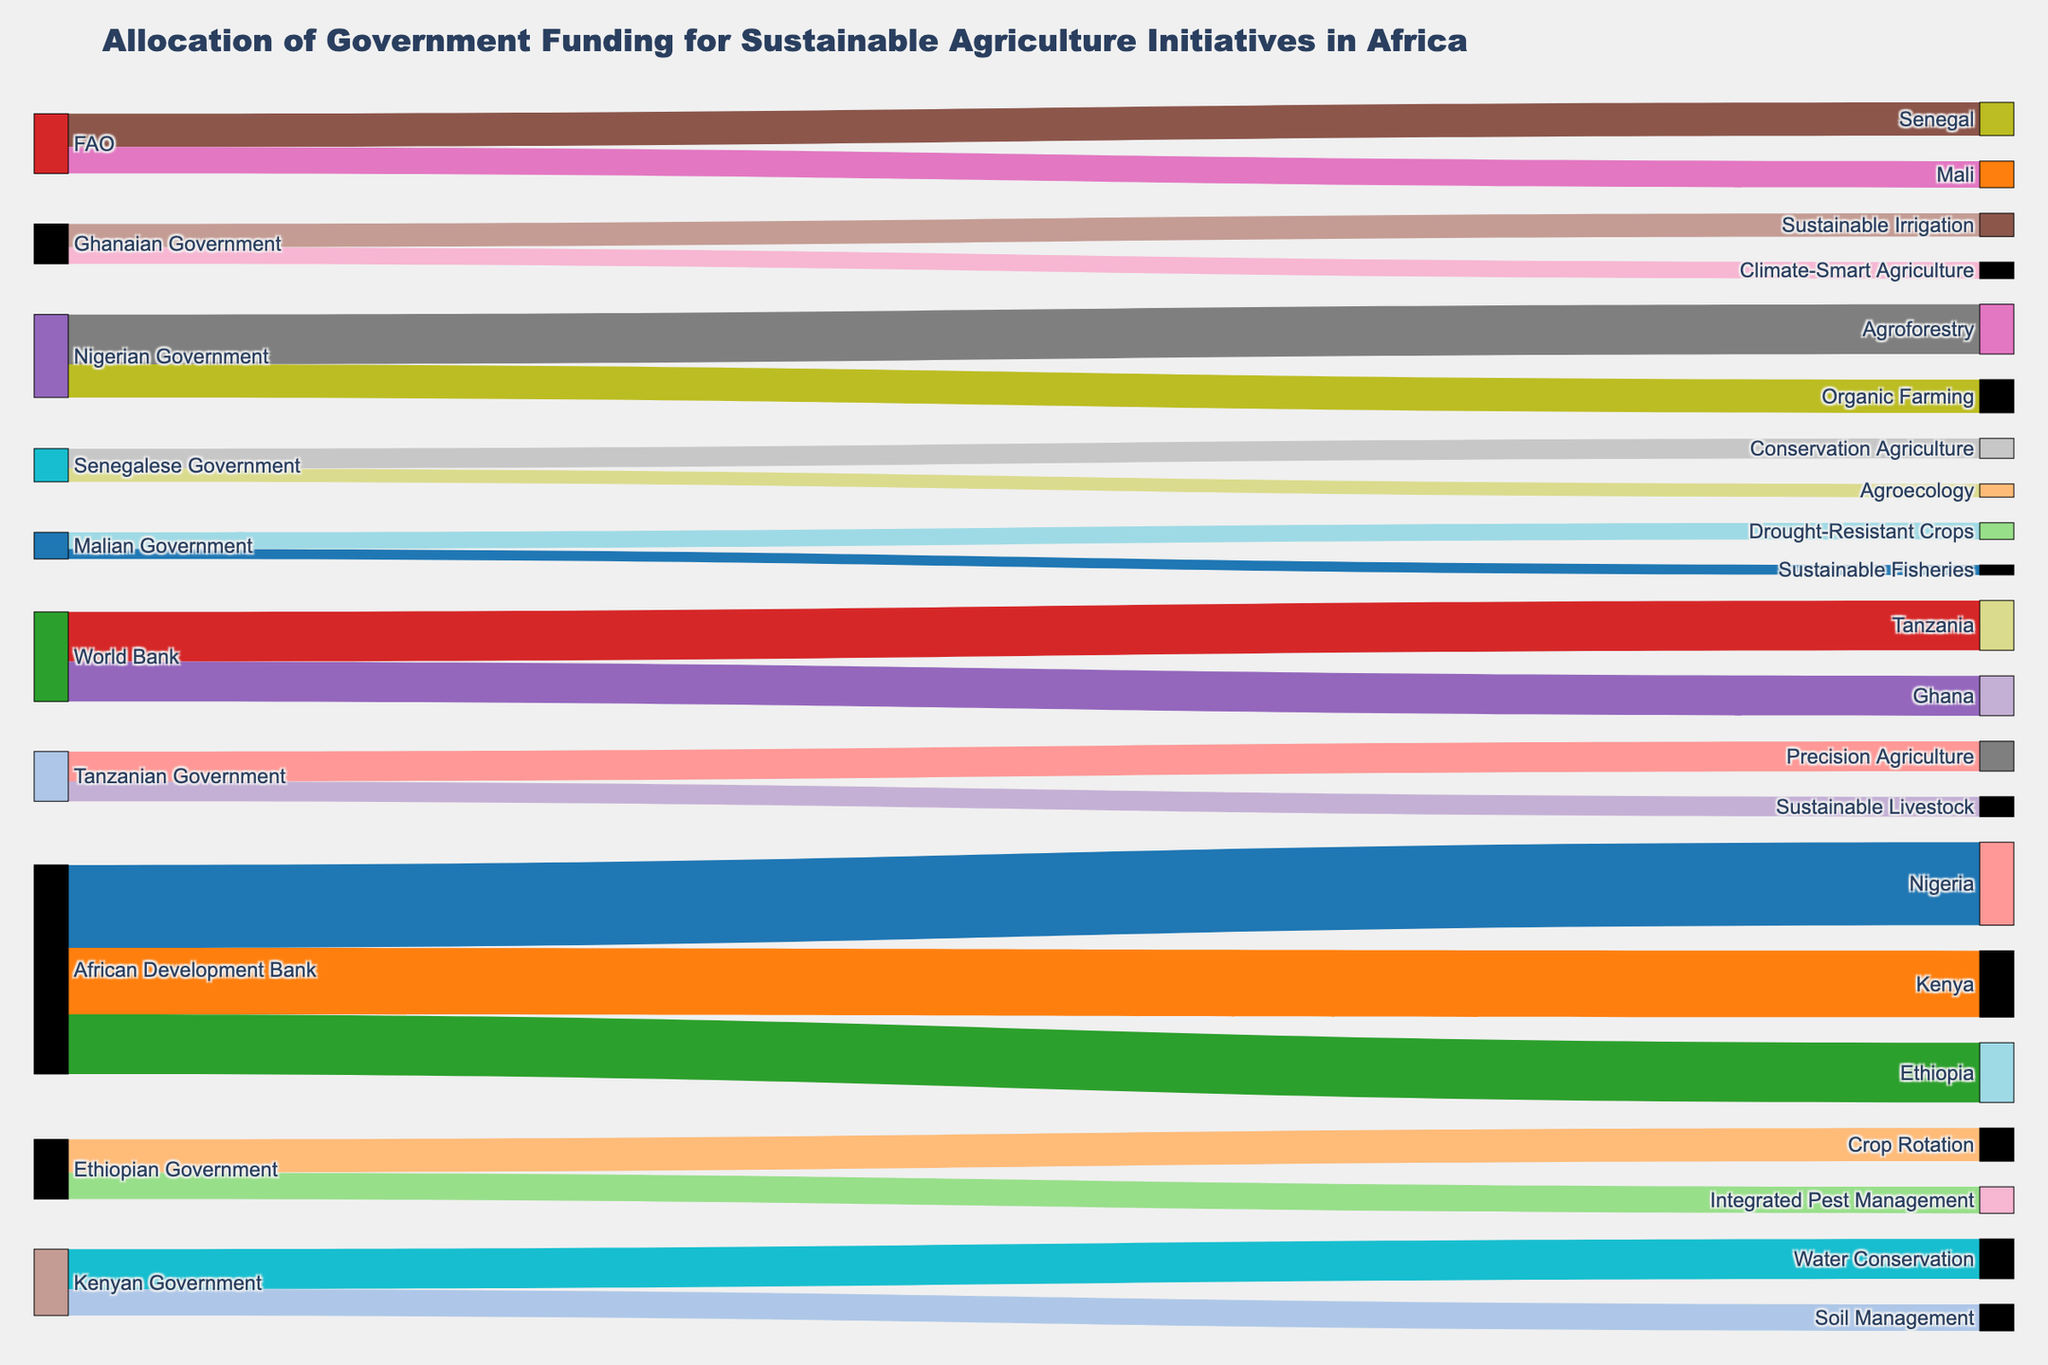Which donor organization provided the most funding? Observing the height of the bars (representing the funding value) linked with each donor organization, African Development Bank has the tallest bar.
Answer: African Development Bank What sustainable agriculture initiative received the most funding within Nigeria? By tracing the flows from 'Nigerian Government,' the largest value (15) leads to 'Agroforestry.'
Answer: Agroforestry How much total funding did Kenya receive from all sources? Summing up values directed to Kenya: 20 (from African Development Bank) + 12 (Kenyan Government) + 8 (Kenyan Government) = 40.
Answer: 40 Which country received funding for soil management? Identify the flow directed to 'Soil Management,' which comes from 'Kenyan Government.'
Answer: Kenya Compare the total funding allocated to Tanzania and Ghana. Which country received more? Calculate total for Tanzania (15 + 9 + 6 = 30) and Ghana (12 + 7 + 5 = 24); Tanzania received more.
Answer: Tanzania What is the overall funding provided by the World Bank? Add up the funding values from 'World Bank': 15 (Tanzania) + 12 (Ghana) = 27.
Answer: 27 Which country received funding for both climate-smart agriculture and sustainable irrigation? Identify the flows directed to these initiatives: Both lead to 'Ghana.'
Answer: Ghana How much funding did Senegal receive for conservation agriculture and agroecology combined? Add values for these initiatives: 6 (Conservation Agriculture) + 4 (Agroecology) = 10.
Answer: 10 Which sustainable agriculture initiative received funding from both governmental and non-governmental sources? Trace any flows coinciding at an initiative node; 'None match this criterion as initiatives are funded by either governments or organizations exclusively.'
Answer: None 